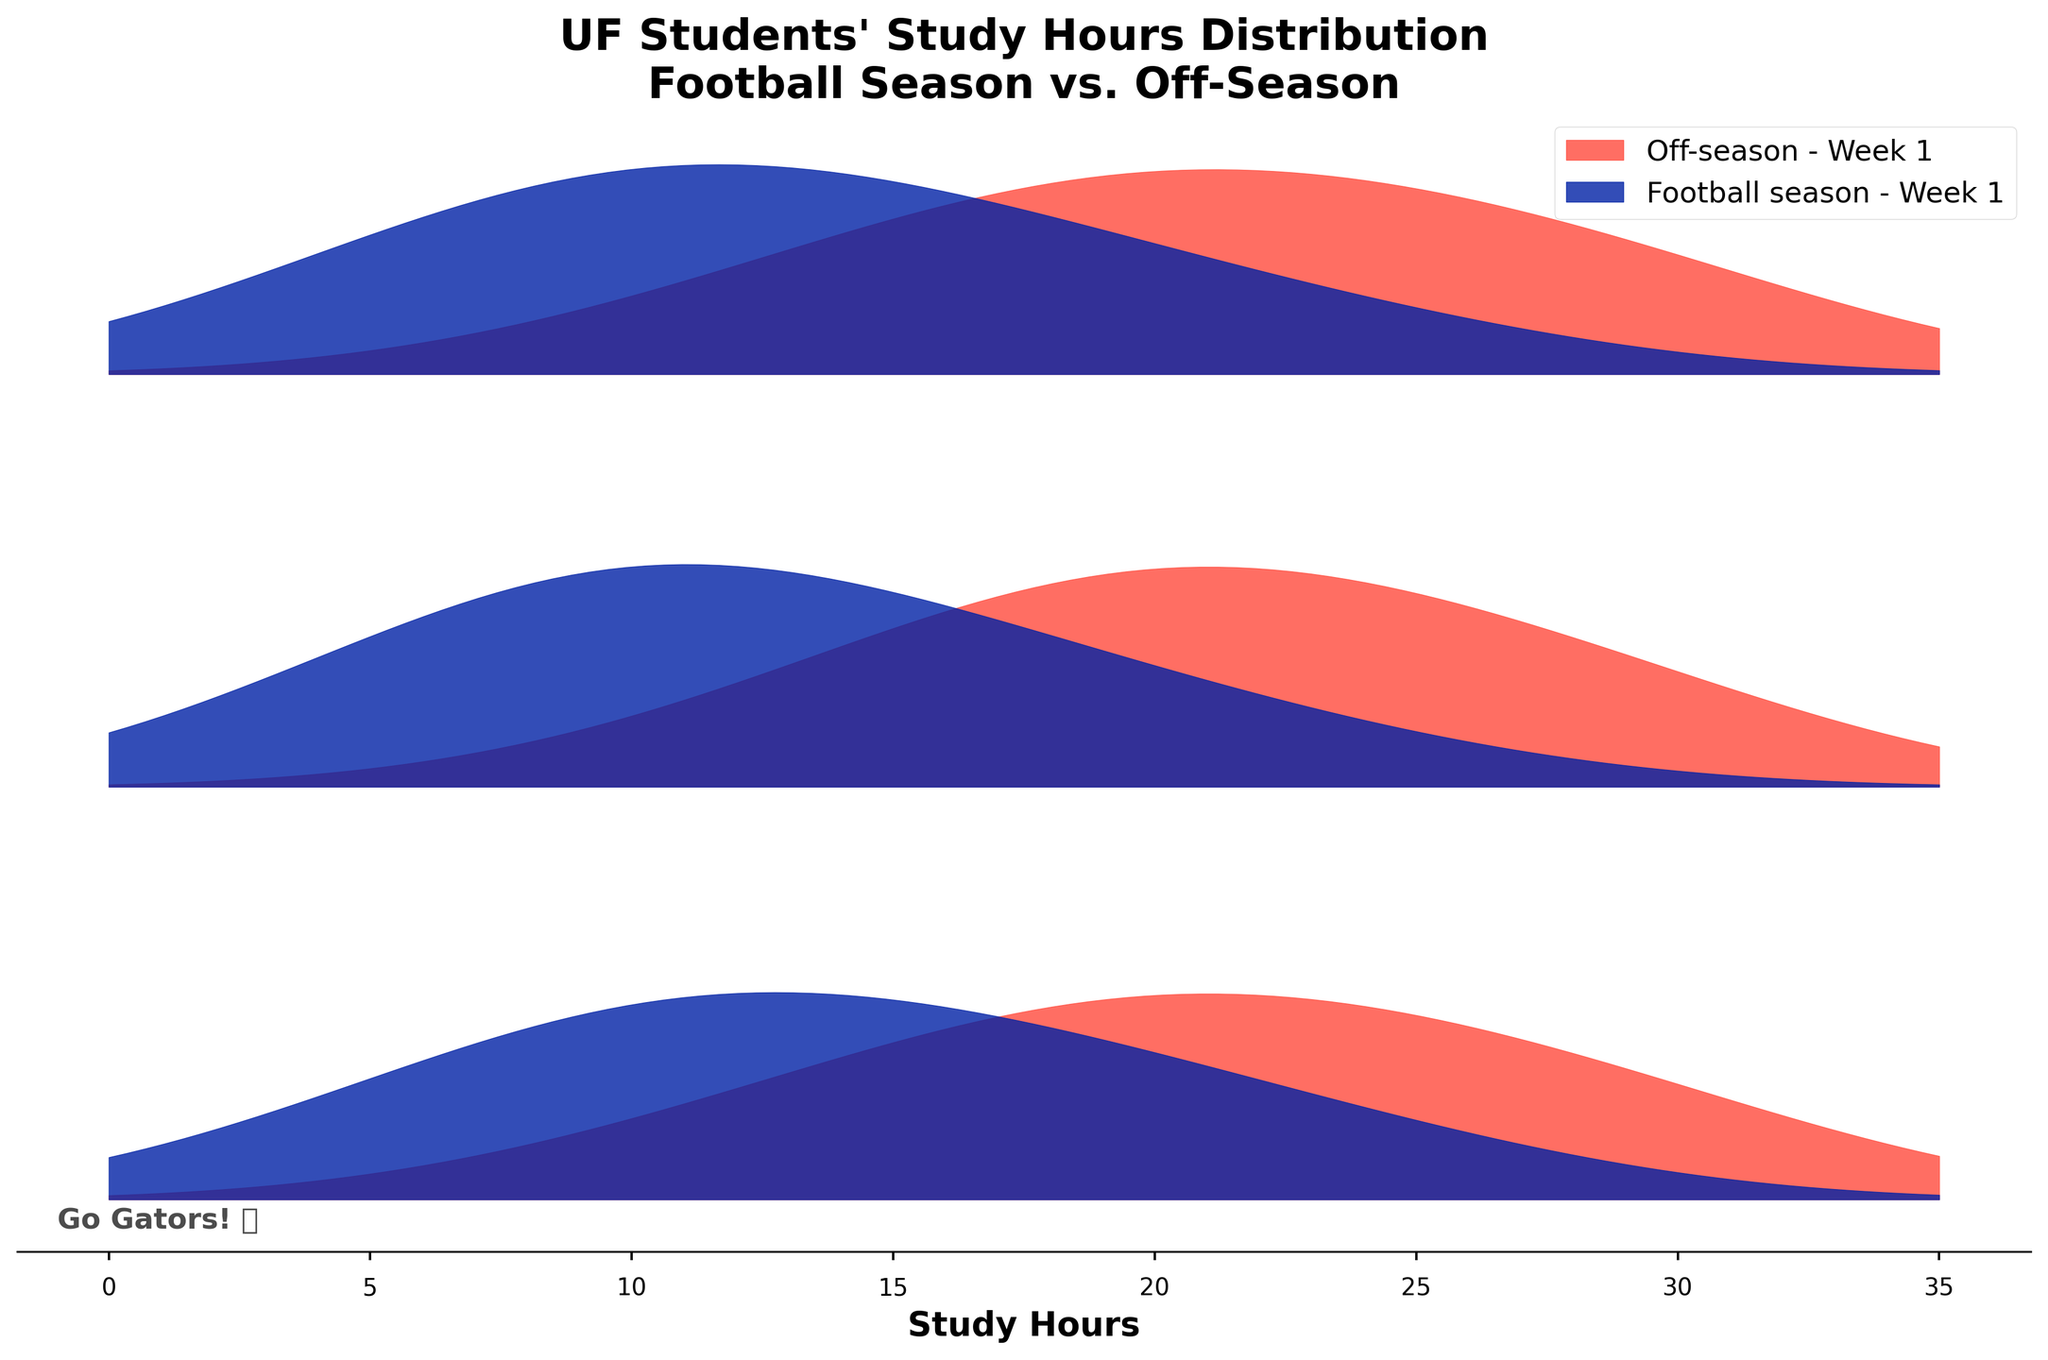What's the title of the graph? The title is usually found at the top of the graph. It gives an overview of what the graph represents.
Answer: "UF Students' Study Hours Distribution\nFootball Season vs. Off-Season" Which periods are compared in this graph? The legend and plot colors indicate the periods being compared. There are two distinct colors representing different periods.
Answer: Football season and Off-season What are the colors representing each period? The legend uses colors to distinguish between the periods. The colors on the plot match with the respective period labels.
Answer: Football season is blue, and Off-season is orange Which period shows a higher density around 10 study hours for Week 12? By looking at the height of the density curves at the 10-hour mark for Week 12, we can compare which is higher.
Answer: Football season What's the highest density value for Off-season in Week 12? The highest point on the Off-season density curve for Week 12 indicates the maximum density.
Answer: 0.09 In Week 6, does the Football season tend to have more students studying 5 hours compared to the Off-season? By comparing the heights of the density curves at the 5-hour mark for Week 6.
Answer: Yes What's the trend in study hours from Week 1 to Week 12 during the Football season? Observing the shift in the peaks and overall shape of the distribution for the Football season from Week 1 to Week 12.
Answer: Peak density increases for lower study hours (5-10 hours) Compare the study hour distribution between Football season and Off-season in Week 1. Which one appears to have more spread? By looking at the range and spread of the density curves for both periods in Week 1.
Answer: Off-season has more spread For Week 12, which period has greater variability in study hours? You can determine variability by observing the spread of the density curves; a wider curve usually suggests more variability.
Answer: Off-season How does the study hour distribution change from Week 1 to Week 6 for Off-season? By comparing the density curves for Off-season in Week 1 and Week 6, noting the shift or spread in the curves.
Answer: The peak density slightly decreases and shifts to lower study hours (15-20 hours) 